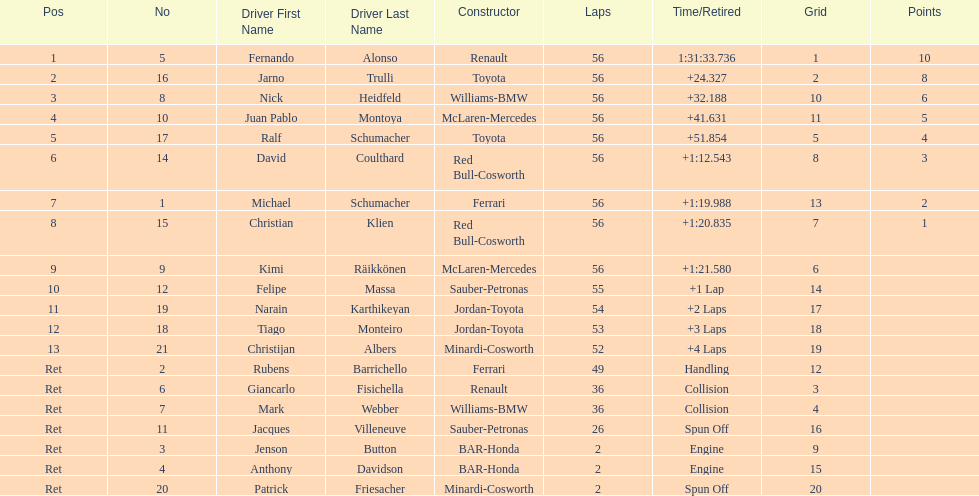What were the total number of laps completed by the 1st position winner? 56. 